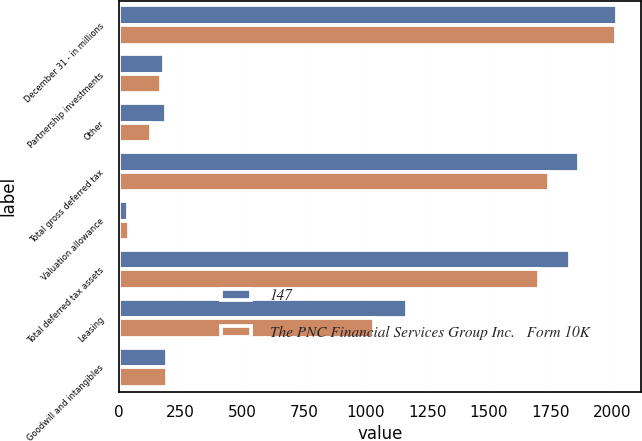Convert chart to OTSL. <chart><loc_0><loc_0><loc_500><loc_500><stacked_bar_chart><ecel><fcel>December 31 - in millions<fcel>Partnership investments<fcel>Other<fcel>Total gross deferred tax<fcel>Valuation allowance<fcel>Total deferred tax assets<fcel>Leasing<fcel>Goodwill and intangibles<nl><fcel>147<fcel>2018<fcel>184<fcel>193<fcel>1866<fcel>37<fcel>1829<fcel>1169<fcel>196<nl><fcel>The PNC Financial Services Group Inc.   Form 10K<fcel>2017<fcel>173<fcel>131<fcel>1743<fcel>40<fcel>1703<fcel>1034<fcel>197<nl></chart> 